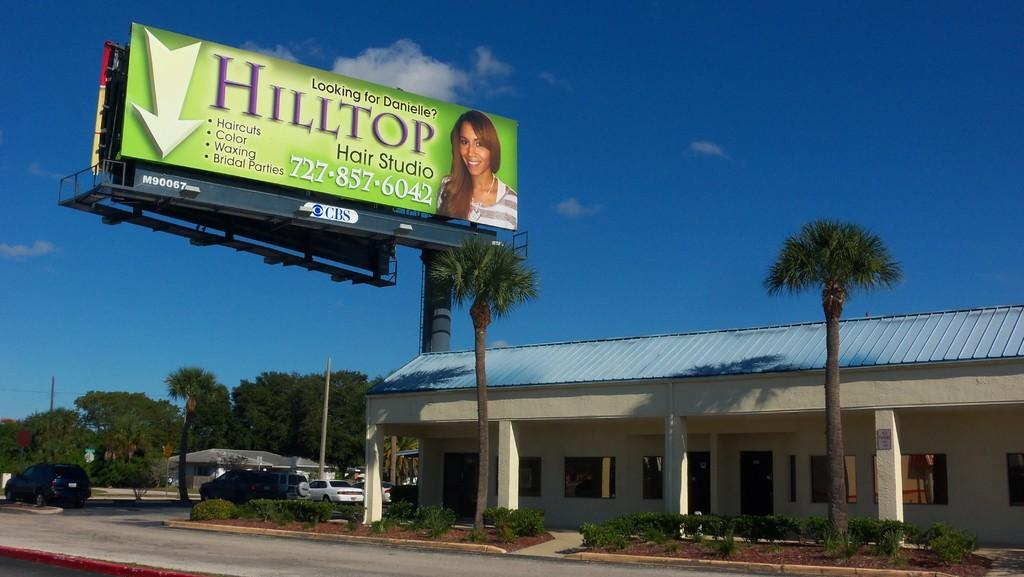<image>
Summarize the visual content of the image. a building with a billboard saying Hilltop on it 